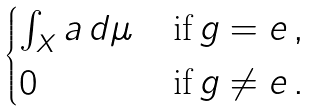Convert formula to latex. <formula><loc_0><loc_0><loc_500><loc_500>\begin{cases} \int _ { X } a \, d \mu & \, \text {if} \, g = e \, , \\ 0 & \, \text {if} \, g \neq e \, . \end{cases}</formula> 